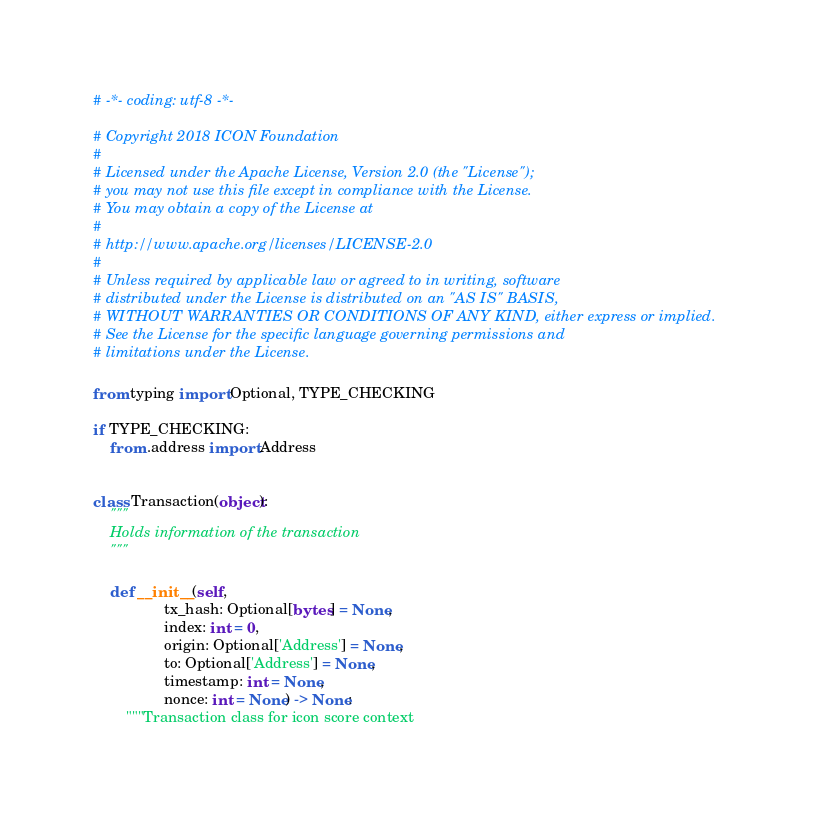Convert code to text. <code><loc_0><loc_0><loc_500><loc_500><_Python_># -*- coding: utf-8 -*-

# Copyright 2018 ICON Foundation
#
# Licensed under the Apache License, Version 2.0 (the "License");
# you may not use this file except in compliance with the License.
# You may obtain a copy of the License at
#
# http://www.apache.org/licenses/LICENSE-2.0
#
# Unless required by applicable law or agreed to in writing, software
# distributed under the License is distributed on an "AS IS" BASIS,
# WITHOUT WARRANTIES OR CONDITIONS OF ANY KIND, either express or implied.
# See the License for the specific language governing permissions and
# limitations under the License.

from typing import Optional, TYPE_CHECKING

if TYPE_CHECKING:
    from .address import Address


class Transaction(object):
    """
    Holds information of the transaction
    """

    def __init__(self,
                 tx_hash: Optional[bytes] = None,
                 index: int = 0,
                 origin: Optional['Address'] = None,
                 to: Optional['Address'] = None,
                 timestamp: int = None,
                 nonce: int = None) -> None:
        """Transaction class for icon score context</code> 